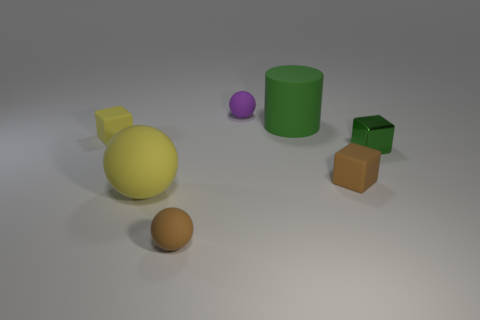Subtract all brown balls. How many balls are left? 2 Add 1 big brown rubber cubes. How many objects exist? 8 Subtract all green cubes. How many cubes are left? 2 Subtract all yellow cylinders. How many gray cubes are left? 0 Subtract all balls. How many objects are left? 4 Subtract 1 spheres. How many spheres are left? 2 Subtract all red cylinders. Subtract all cyan cubes. How many cylinders are left? 1 Subtract all yellow things. Subtract all brown objects. How many objects are left? 3 Add 4 small brown balls. How many small brown balls are left? 5 Add 6 small yellow shiny cylinders. How many small yellow shiny cylinders exist? 6 